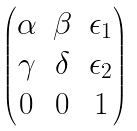Convert formula to latex. <formula><loc_0><loc_0><loc_500><loc_500>\begin{pmatrix} \alpha & \beta & \epsilon _ { 1 } \\ \gamma & \delta & \epsilon _ { 2 } \\ 0 & 0 & 1 \\ \end{pmatrix}</formula> 